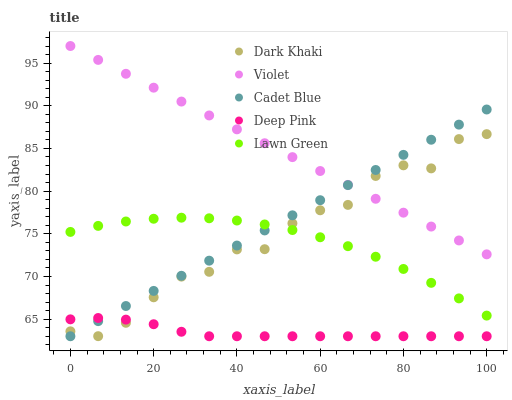Does Deep Pink have the minimum area under the curve?
Answer yes or no. Yes. Does Violet have the maximum area under the curve?
Answer yes or no. Yes. Does Lawn Green have the minimum area under the curve?
Answer yes or no. No. Does Lawn Green have the maximum area under the curve?
Answer yes or no. No. Is Cadet Blue the smoothest?
Answer yes or no. Yes. Is Dark Khaki the roughest?
Answer yes or no. Yes. Is Lawn Green the smoothest?
Answer yes or no. No. Is Lawn Green the roughest?
Answer yes or no. No. Does Cadet Blue have the lowest value?
Answer yes or no. Yes. Does Lawn Green have the lowest value?
Answer yes or no. No. Does Violet have the highest value?
Answer yes or no. Yes. Does Lawn Green have the highest value?
Answer yes or no. No. Is Deep Pink less than Lawn Green?
Answer yes or no. Yes. Is Violet greater than Deep Pink?
Answer yes or no. Yes. Does Dark Khaki intersect Violet?
Answer yes or no. Yes. Is Dark Khaki less than Violet?
Answer yes or no. No. Is Dark Khaki greater than Violet?
Answer yes or no. No. Does Deep Pink intersect Lawn Green?
Answer yes or no. No. 